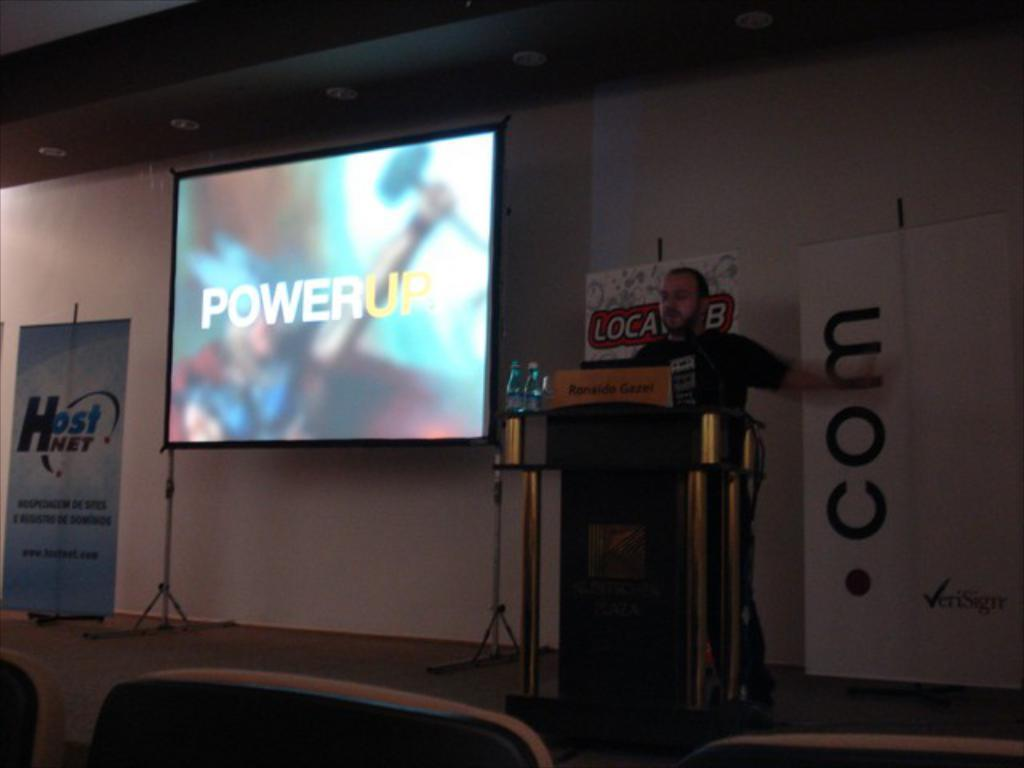<image>
Offer a succinct explanation of the picture presented. A man is on stage with a slide in the back saying Powerup 